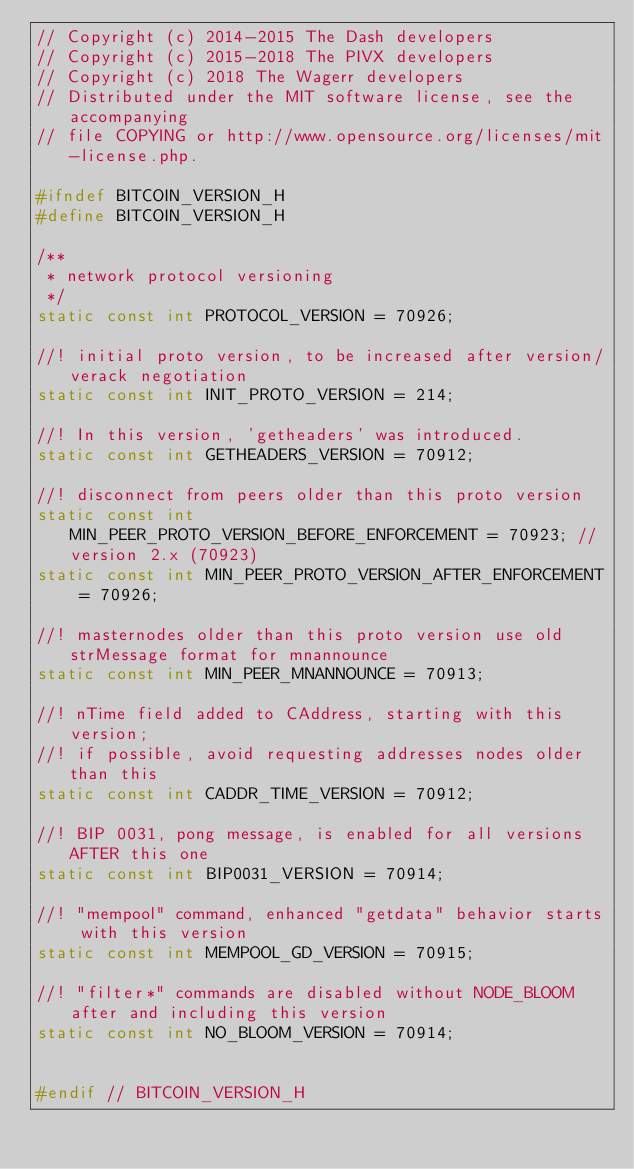Convert code to text. <code><loc_0><loc_0><loc_500><loc_500><_C_>// Copyright (c) 2014-2015 The Dash developers
// Copyright (c) 2015-2018 The PIVX developers
// Copyright (c) 2018 The Wagerr developers
// Distributed under the MIT software license, see the accompanying
// file COPYING or http://www.opensource.org/licenses/mit-license.php.

#ifndef BITCOIN_VERSION_H
#define BITCOIN_VERSION_H

/**
 * network protocol versioning
 */
static const int PROTOCOL_VERSION = 70926;

//! initial proto version, to be increased after version/verack negotiation
static const int INIT_PROTO_VERSION = 214;

//! In this version, 'getheaders' was introduced.
static const int GETHEADERS_VERSION = 70912;

//! disconnect from peers older than this proto version
static const int MIN_PEER_PROTO_VERSION_BEFORE_ENFORCEMENT = 70923; //version 2.x (70923)
static const int MIN_PEER_PROTO_VERSION_AFTER_ENFORCEMENT = 70926;

//! masternodes older than this proto version use old strMessage format for mnannounce
static const int MIN_PEER_MNANNOUNCE = 70913;

//! nTime field added to CAddress, starting with this version;
//! if possible, avoid requesting addresses nodes older than this
static const int CADDR_TIME_VERSION = 70912;

//! BIP 0031, pong message, is enabled for all versions AFTER this one
static const int BIP0031_VERSION = 70914;

//! "mempool" command, enhanced "getdata" behavior starts with this version
static const int MEMPOOL_GD_VERSION = 70915;

//! "filter*" commands are disabled without NODE_BLOOM after and including this version
static const int NO_BLOOM_VERSION = 70914;


#endif // BITCOIN_VERSION_H
</code> 